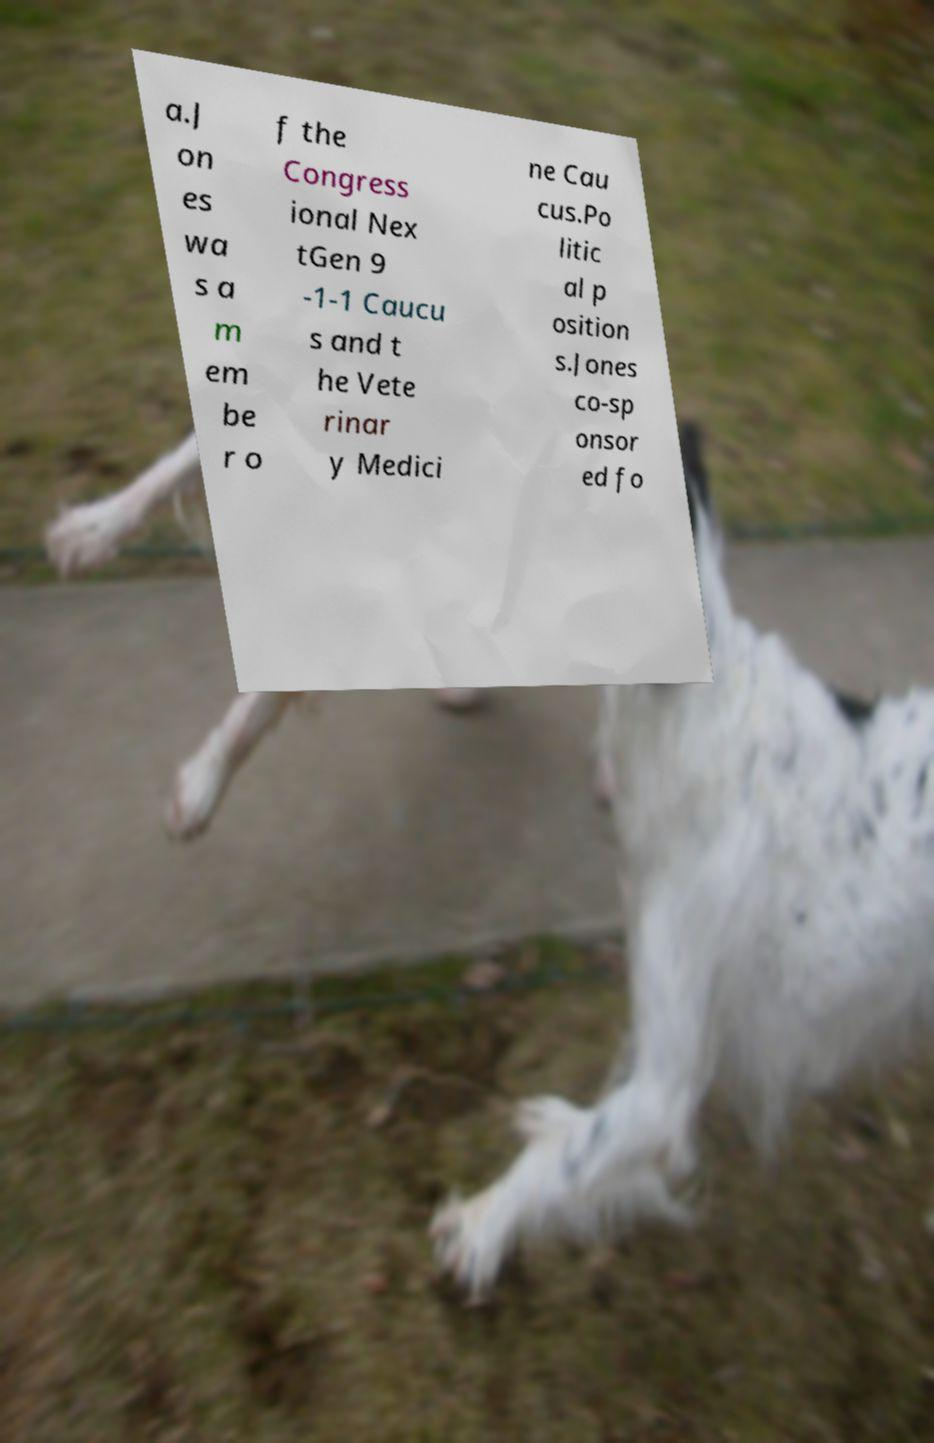Could you extract and type out the text from this image? a.J on es wa s a m em be r o f the Congress ional Nex tGen 9 -1-1 Caucu s and t he Vete rinar y Medici ne Cau cus.Po litic al p osition s.Jones co-sp onsor ed fo 